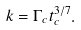<formula> <loc_0><loc_0><loc_500><loc_500>k = \Gamma _ { c } t _ { c } ^ { 3 / 7 } .</formula> 